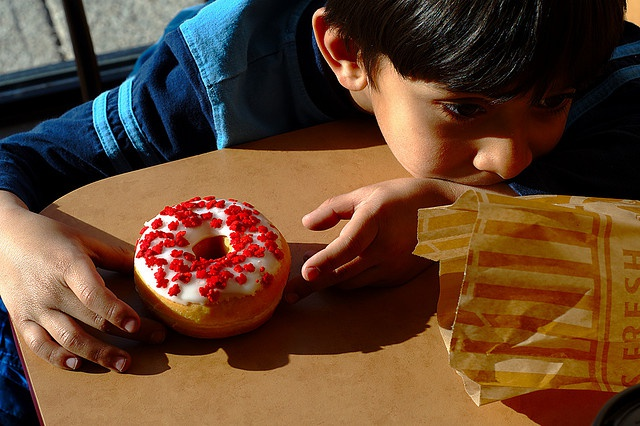Describe the objects in this image and their specific colors. I can see dining table in gray, tan, olive, black, and maroon tones, people in gray, black, maroon, tan, and navy tones, and donut in gray, maroon, red, and black tones in this image. 